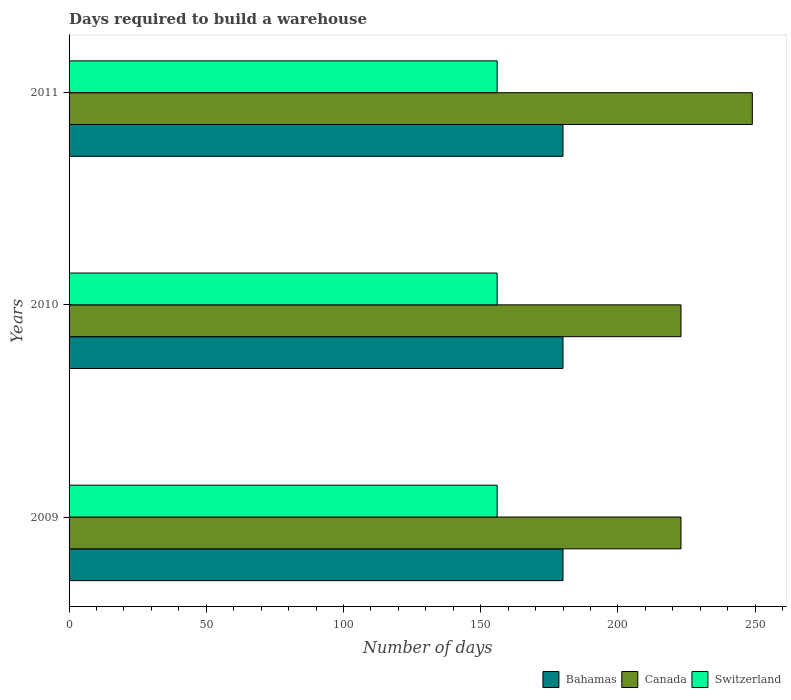Are the number of bars per tick equal to the number of legend labels?
Your answer should be very brief. Yes. How many bars are there on the 1st tick from the top?
Your response must be concise. 3. How many bars are there on the 3rd tick from the bottom?
Ensure brevity in your answer.  3. In how many cases, is the number of bars for a given year not equal to the number of legend labels?
Ensure brevity in your answer.  0. What is the days required to build a warehouse in in Canada in 2009?
Provide a short and direct response. 223. Across all years, what is the maximum days required to build a warehouse in in Canada?
Make the answer very short. 249. Across all years, what is the minimum days required to build a warehouse in in Bahamas?
Your answer should be compact. 180. In which year was the days required to build a warehouse in in Bahamas maximum?
Give a very brief answer. 2009. In which year was the days required to build a warehouse in in Switzerland minimum?
Make the answer very short. 2009. What is the total days required to build a warehouse in in Bahamas in the graph?
Your answer should be very brief. 540. What is the difference between the days required to build a warehouse in in Bahamas in 2009 and that in 2010?
Your answer should be very brief. 0. What is the average days required to build a warehouse in in Bahamas per year?
Provide a succinct answer. 180. In the year 2011, what is the difference between the days required to build a warehouse in in Switzerland and days required to build a warehouse in in Canada?
Your answer should be compact. -93. What is the ratio of the days required to build a warehouse in in Switzerland in 2009 to that in 2010?
Offer a very short reply. 1. What is the difference between the highest and the second highest days required to build a warehouse in in Canada?
Ensure brevity in your answer.  26. In how many years, is the days required to build a warehouse in in Canada greater than the average days required to build a warehouse in in Canada taken over all years?
Ensure brevity in your answer.  1. What does the 2nd bar from the top in 2010 represents?
Offer a terse response. Canada. What does the 1st bar from the bottom in 2011 represents?
Ensure brevity in your answer.  Bahamas. What is the difference between two consecutive major ticks on the X-axis?
Your answer should be very brief. 50. Where does the legend appear in the graph?
Give a very brief answer. Bottom right. How many legend labels are there?
Keep it short and to the point. 3. How are the legend labels stacked?
Give a very brief answer. Horizontal. What is the title of the graph?
Keep it short and to the point. Days required to build a warehouse. Does "Latin America(developing only)" appear as one of the legend labels in the graph?
Offer a terse response. No. What is the label or title of the X-axis?
Provide a succinct answer. Number of days. What is the Number of days in Bahamas in 2009?
Your answer should be very brief. 180. What is the Number of days in Canada in 2009?
Keep it short and to the point. 223. What is the Number of days in Switzerland in 2009?
Give a very brief answer. 156. What is the Number of days of Bahamas in 2010?
Give a very brief answer. 180. What is the Number of days of Canada in 2010?
Keep it short and to the point. 223. What is the Number of days of Switzerland in 2010?
Your answer should be very brief. 156. What is the Number of days in Bahamas in 2011?
Provide a succinct answer. 180. What is the Number of days of Canada in 2011?
Your answer should be compact. 249. What is the Number of days of Switzerland in 2011?
Give a very brief answer. 156. Across all years, what is the maximum Number of days of Bahamas?
Your answer should be very brief. 180. Across all years, what is the maximum Number of days of Canada?
Ensure brevity in your answer.  249. Across all years, what is the maximum Number of days in Switzerland?
Offer a very short reply. 156. Across all years, what is the minimum Number of days of Bahamas?
Give a very brief answer. 180. Across all years, what is the minimum Number of days in Canada?
Ensure brevity in your answer.  223. Across all years, what is the minimum Number of days of Switzerland?
Make the answer very short. 156. What is the total Number of days in Bahamas in the graph?
Your answer should be very brief. 540. What is the total Number of days of Canada in the graph?
Make the answer very short. 695. What is the total Number of days of Switzerland in the graph?
Provide a succinct answer. 468. What is the difference between the Number of days of Bahamas in 2009 and that in 2010?
Your answer should be very brief. 0. What is the difference between the Number of days in Canada in 2009 and that in 2010?
Your answer should be very brief. 0. What is the difference between the Number of days in Canada in 2009 and that in 2011?
Give a very brief answer. -26. What is the difference between the Number of days of Switzerland in 2009 and that in 2011?
Provide a succinct answer. 0. What is the difference between the Number of days in Switzerland in 2010 and that in 2011?
Your answer should be compact. 0. What is the difference between the Number of days of Bahamas in 2009 and the Number of days of Canada in 2010?
Ensure brevity in your answer.  -43. What is the difference between the Number of days of Canada in 2009 and the Number of days of Switzerland in 2010?
Offer a terse response. 67. What is the difference between the Number of days in Bahamas in 2009 and the Number of days in Canada in 2011?
Make the answer very short. -69. What is the difference between the Number of days in Bahamas in 2009 and the Number of days in Switzerland in 2011?
Your answer should be compact. 24. What is the difference between the Number of days of Bahamas in 2010 and the Number of days of Canada in 2011?
Give a very brief answer. -69. What is the average Number of days in Bahamas per year?
Provide a succinct answer. 180. What is the average Number of days of Canada per year?
Your answer should be compact. 231.67. What is the average Number of days in Switzerland per year?
Make the answer very short. 156. In the year 2009, what is the difference between the Number of days in Bahamas and Number of days in Canada?
Your response must be concise. -43. In the year 2009, what is the difference between the Number of days in Canada and Number of days in Switzerland?
Your answer should be very brief. 67. In the year 2010, what is the difference between the Number of days in Bahamas and Number of days in Canada?
Ensure brevity in your answer.  -43. In the year 2010, what is the difference between the Number of days of Bahamas and Number of days of Switzerland?
Your answer should be compact. 24. In the year 2010, what is the difference between the Number of days of Canada and Number of days of Switzerland?
Give a very brief answer. 67. In the year 2011, what is the difference between the Number of days of Bahamas and Number of days of Canada?
Offer a very short reply. -69. In the year 2011, what is the difference between the Number of days of Bahamas and Number of days of Switzerland?
Your response must be concise. 24. In the year 2011, what is the difference between the Number of days of Canada and Number of days of Switzerland?
Make the answer very short. 93. What is the ratio of the Number of days in Canada in 2009 to that in 2010?
Offer a terse response. 1. What is the ratio of the Number of days in Switzerland in 2009 to that in 2010?
Keep it short and to the point. 1. What is the ratio of the Number of days in Bahamas in 2009 to that in 2011?
Offer a very short reply. 1. What is the ratio of the Number of days in Canada in 2009 to that in 2011?
Offer a very short reply. 0.9. What is the ratio of the Number of days in Switzerland in 2009 to that in 2011?
Your answer should be very brief. 1. What is the ratio of the Number of days of Canada in 2010 to that in 2011?
Make the answer very short. 0.9. What is the difference between the highest and the second highest Number of days of Bahamas?
Your answer should be compact. 0. What is the difference between the highest and the second highest Number of days of Switzerland?
Provide a succinct answer. 0. What is the difference between the highest and the lowest Number of days in Bahamas?
Give a very brief answer. 0. What is the difference between the highest and the lowest Number of days of Canada?
Make the answer very short. 26. 